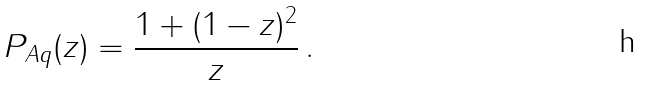Convert formula to latex. <formula><loc_0><loc_0><loc_500><loc_500>P _ { A q } ( z ) = \frac { 1 + ( 1 - z ) ^ { 2 } } { z } \, .</formula> 